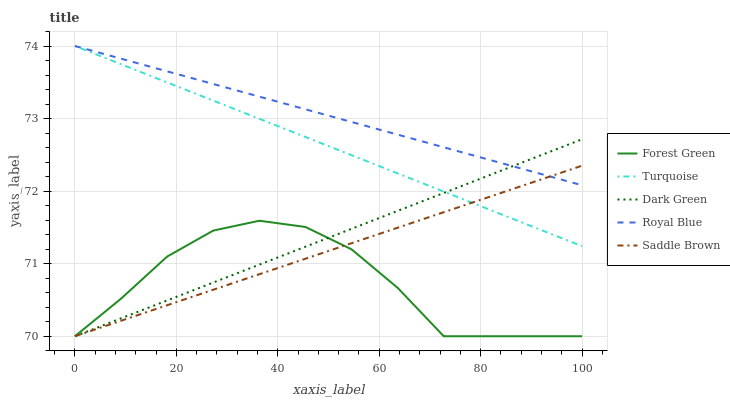Does Forest Green have the minimum area under the curve?
Answer yes or no. Yes. Does Royal Blue have the maximum area under the curve?
Answer yes or no. Yes. Does Royal Blue have the minimum area under the curve?
Answer yes or no. No. Does Forest Green have the maximum area under the curve?
Answer yes or no. No. Is Dark Green the smoothest?
Answer yes or no. Yes. Is Forest Green the roughest?
Answer yes or no. Yes. Is Royal Blue the smoothest?
Answer yes or no. No. Is Royal Blue the roughest?
Answer yes or no. No. Does Saddle Brown have the lowest value?
Answer yes or no. Yes. Does Royal Blue have the lowest value?
Answer yes or no. No. Does Turquoise have the highest value?
Answer yes or no. Yes. Does Forest Green have the highest value?
Answer yes or no. No. Is Forest Green less than Turquoise?
Answer yes or no. Yes. Is Turquoise greater than Forest Green?
Answer yes or no. Yes. Does Forest Green intersect Saddle Brown?
Answer yes or no. Yes. Is Forest Green less than Saddle Brown?
Answer yes or no. No. Is Forest Green greater than Saddle Brown?
Answer yes or no. No. Does Forest Green intersect Turquoise?
Answer yes or no. No. 